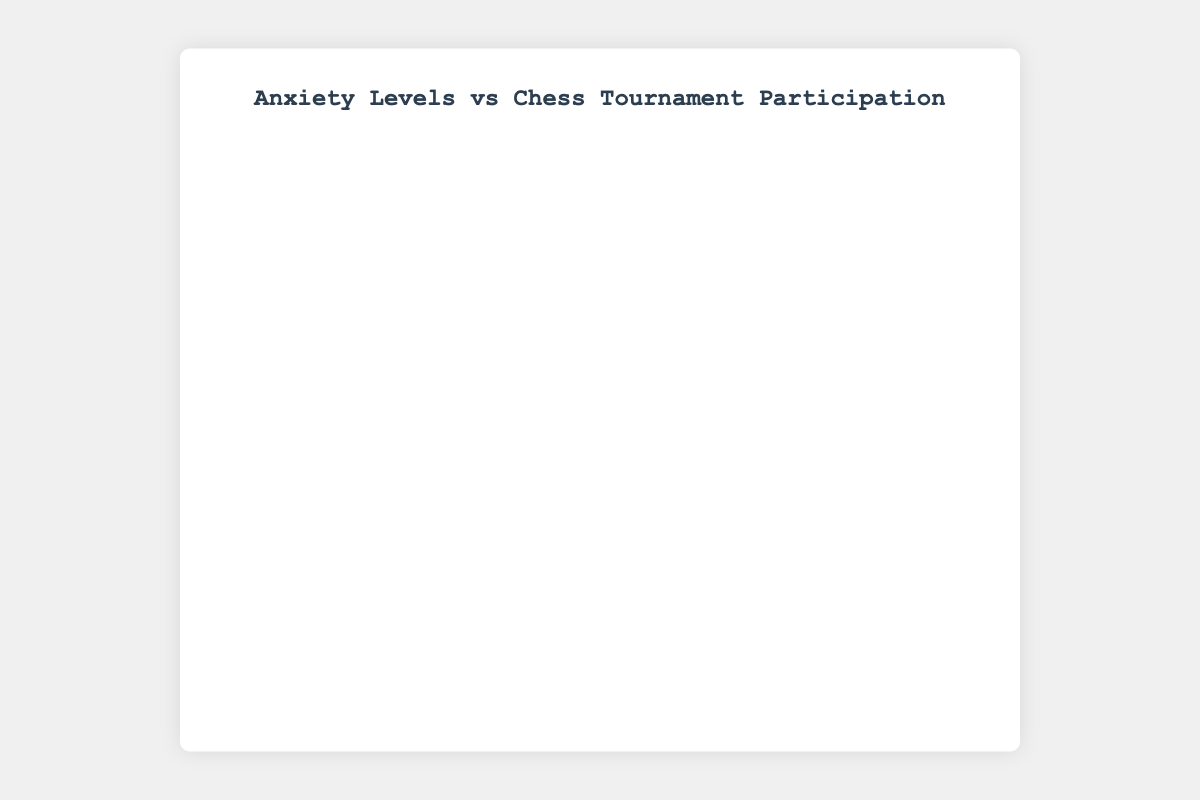How many participants have an anxiety level of 8? To find this, locate the points on the scatter plot where the x-axis (anxiety level) is 8. Count these points.
Answer: 2 What is the highest frequency of chess tournament participation among the participants? Identify the point(s) with the highest y-axis (tournament frequency) value.
Answer: 6 Which participant has the highest anxiety level? Locate the point on the x-axis with the highest value and refer to the hover information to identify the participant.
Answer: P010 What's the average anxiety level of participants who participate in chess tournaments only once a year? Identify points where the y-axis value is 1. Sum the corresponding x-axis values and divide by the number of these points. The points are (P002, P006, P015) with x-values of 7, 8, 8. Average = (7 + 8 + 8) / 3
Answer: 7.67 What is the range of the tournament frequency for participants with anxiety levels less than or equal to 3? Locate points on the x-axis that are ≤ 3. The y-values are 4, 5, 6, 4, 6. The range is the difference between the maximum and minimum values of these y-values.
Answer: 2 Is there a general trend where higher anxiety levels correspond to lower tournament participation? Visually assess the general distribution of points: higher x-values (anxiety levels) have lower y-values (tournament frequencies).
Answer: Yes Compare the average tournament frequency for participants with anxiety levels above the average anxiety level. First, calculate the average anxiety level, which is (4+7+3+6+5+8+2+1+3+9+4+7+5+2+8) / 15 = 5.07. Then, identify points where the anxiety level is above this average (6, 7, 8, 9) and calculate the average of their y-values (2, 1, 1, 0, 2).
Answer: 1.20 How many participants have an average or higher tournament frequency than the annotated 'average tournament frequency' line? Identify points that fall on or above the y=3 annotated line. Count these points to get the number of participants.
Answer: 8 Does the color of the markers provide any additional information? Yes, the color scale represents the anxiety levels, with a color bar labeled 'Anxiety Level'.
Answer: Yes 